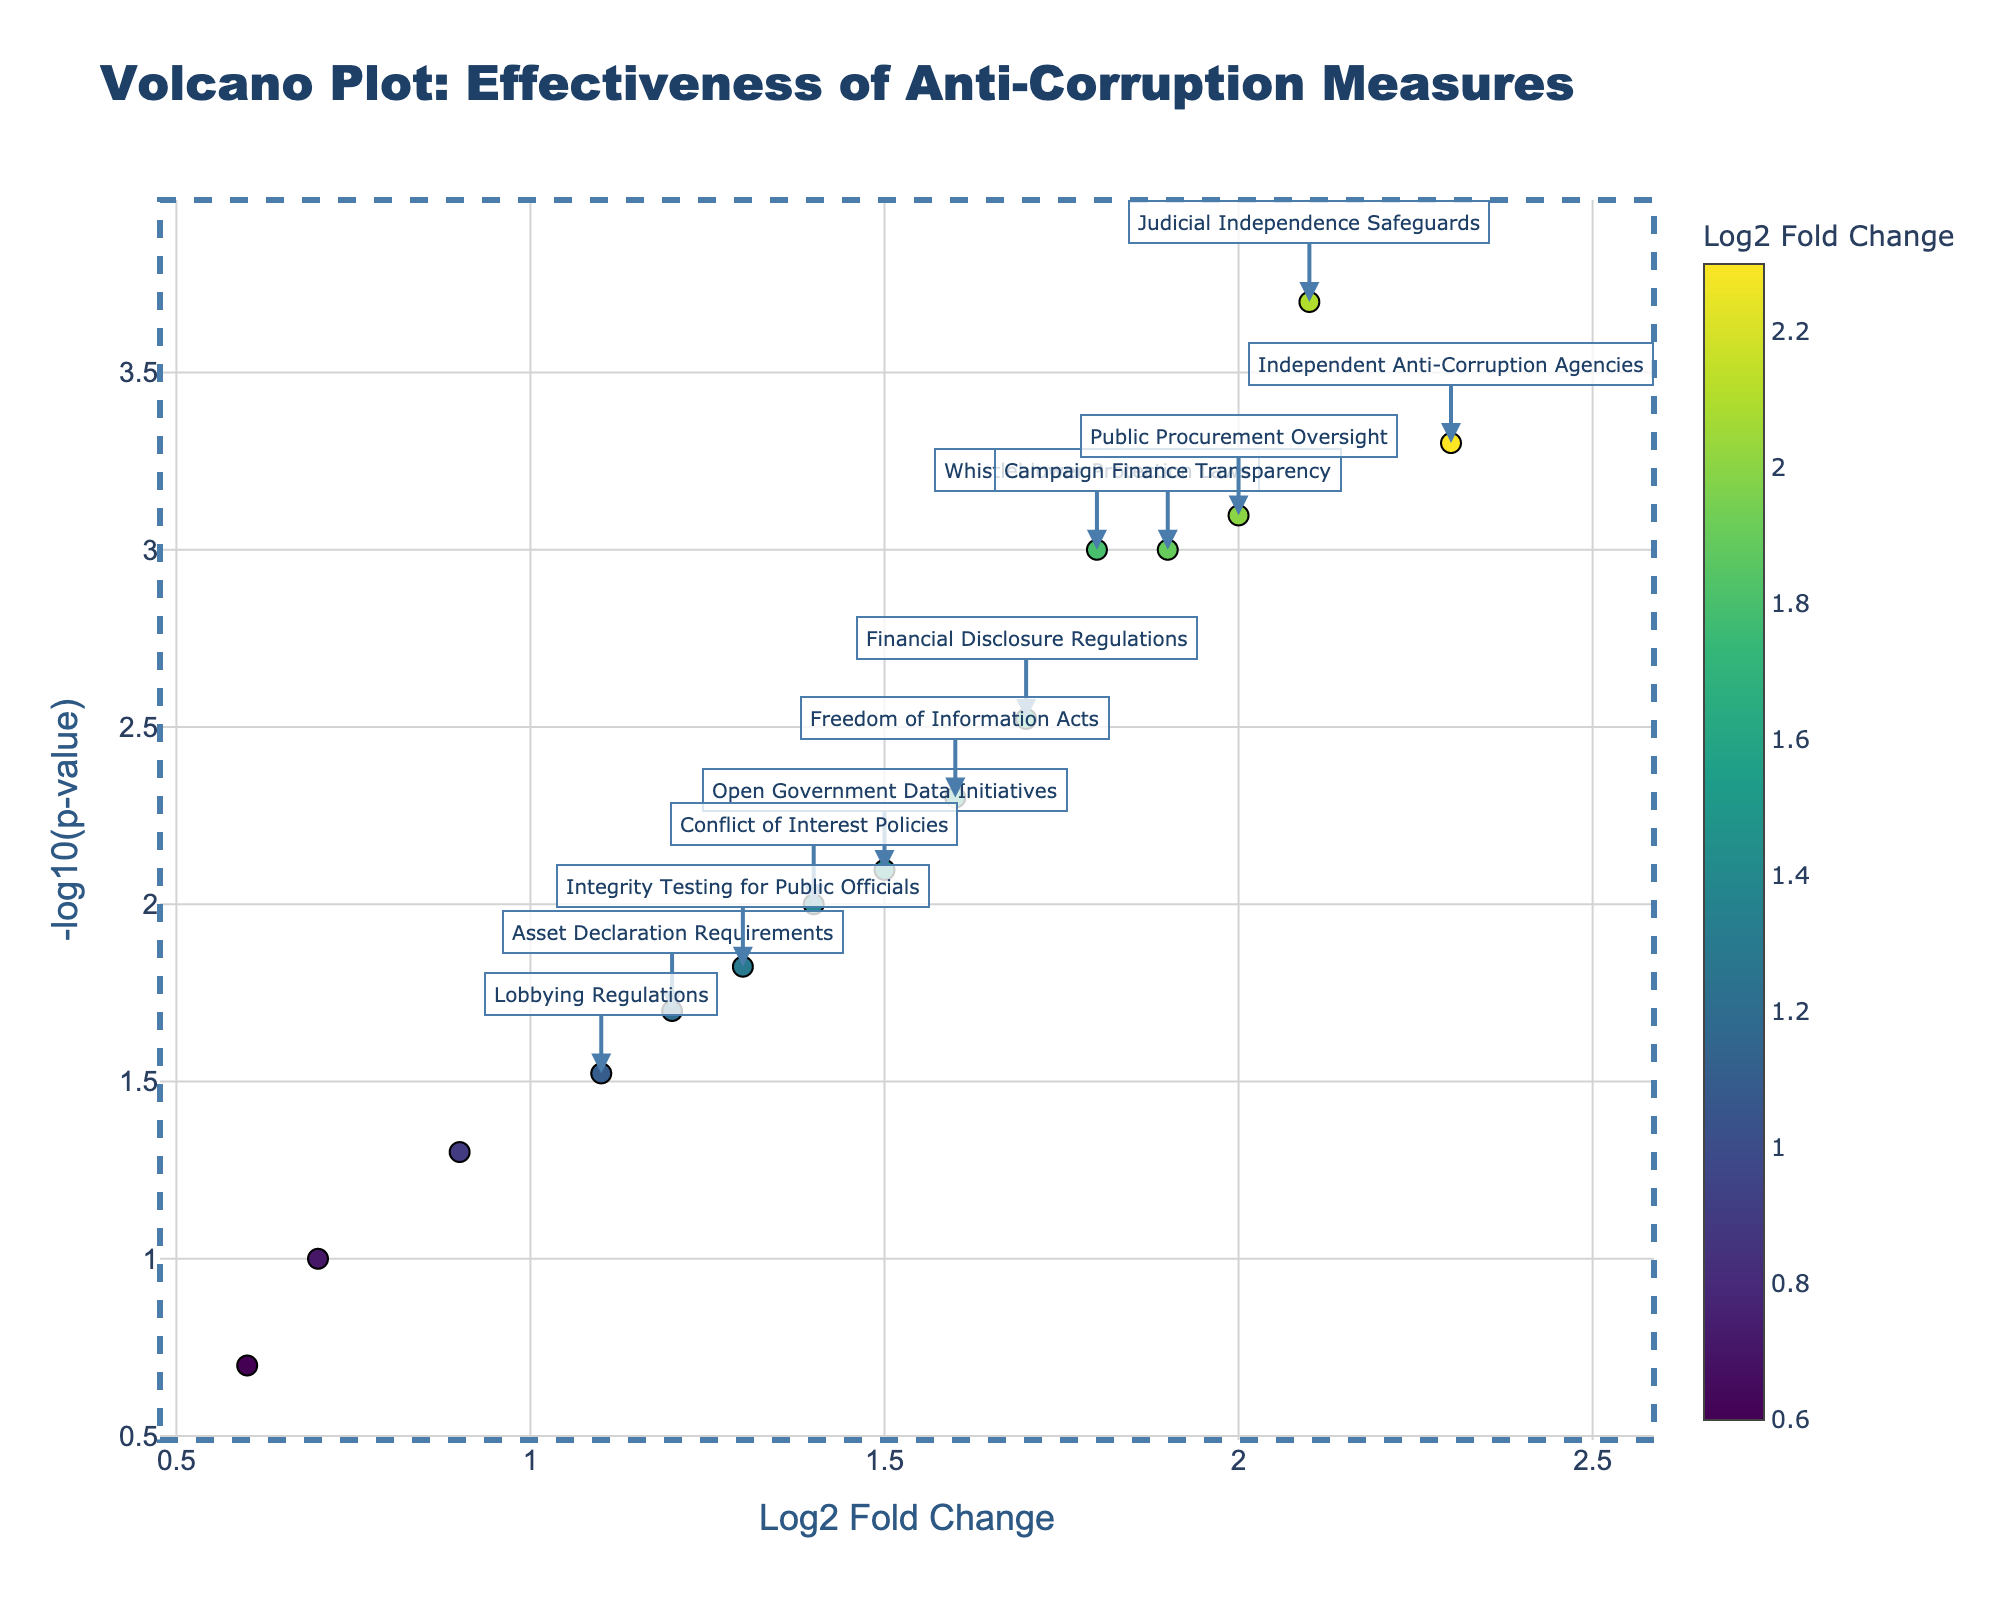how many measures have a log2 fold change greater than 1.0? To answer this, count the number of data points (measures) that have x-values (Log2 Fold Change) greater than 1.0.
Answer: 11 What is the measure with the highest log2 fold change? Locate the measure with the highest x-value on the plot. The highest Log2 Fold Change is 2.3.
Answer: Independent Anti-Corruption Agencies How many measures have p-values less than 0.05 and log2 fold changes greater than 1? Combine both thresholds: p-value (y-axis, -log10(p-value) should be above -log10(0.05) ≈ 1.3) and Log2 Fold Change greater than 1.0 (x-axis > 1.0).
Answer: 8 Which measure has the smallest p-value? Identify the measure with the highest y-value on the plot. The highest value of -log10(p-value) corresponds to the smallest p-value.
Answer: Judicial Independence Safeguards Is there any measure with log2 fold change close to zero and a p-value less than 0.05? Check the center (log2 fold change close to zero) and above the y-threshold (-log10(p-value) > 1.3).
Answer: No Which measure has the lowest log2 fold change and what is its relevance? Find the measure with the lowest x-value (closest to the left side), and check its y-value.
Answer: Ethics Training Programs, p-value = 0.1 How many measures are statistically significant (p < 0.05)? Count the points above the y-threshold (-log10(p-value) > 1.3).
Answer: 12 Which measure has both high log2 fold change and high statistical significance? Look for data points with high x-values (log2 fold change) and high y-values (-log10(p-value)).
Answer: Independent Anti-Corruption Agencies and Judicial Independence Safeguards Which measure related to public officials (e.g., Integrity Testing) has the highest log2 fold change? Locate among the relevant measures, then check their x-value.
Answer: Integrity Testing for Public Officials, log2 fold change = 1.3 